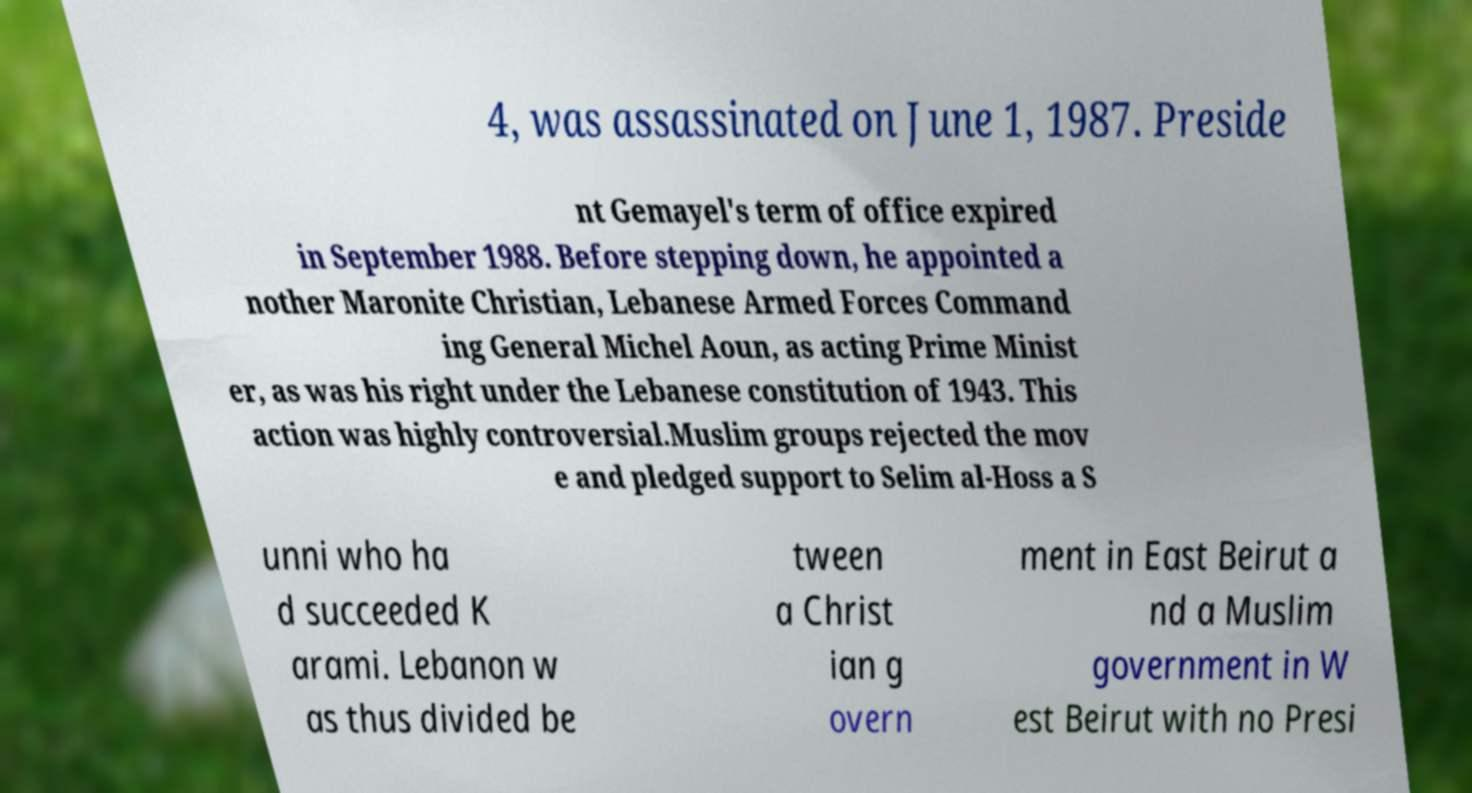Can you accurately transcribe the text from the provided image for me? 4, was assassinated on June 1, 1987. Preside nt Gemayel's term of office expired in September 1988. Before stepping down, he appointed a nother Maronite Christian, Lebanese Armed Forces Command ing General Michel Aoun, as acting Prime Minist er, as was his right under the Lebanese constitution of 1943. This action was highly controversial.Muslim groups rejected the mov e and pledged support to Selim al-Hoss a S unni who ha d succeeded K arami. Lebanon w as thus divided be tween a Christ ian g overn ment in East Beirut a nd a Muslim government in W est Beirut with no Presi 